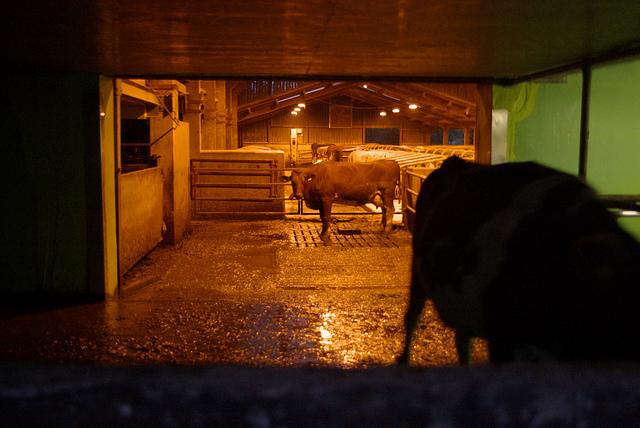How many cows?
Short answer required. 2. The lights of this place are on?
Be succinct. Yes. What animal is in the doorway?
Be succinct. Cow. Is this a living room?
Quick response, please. No. 